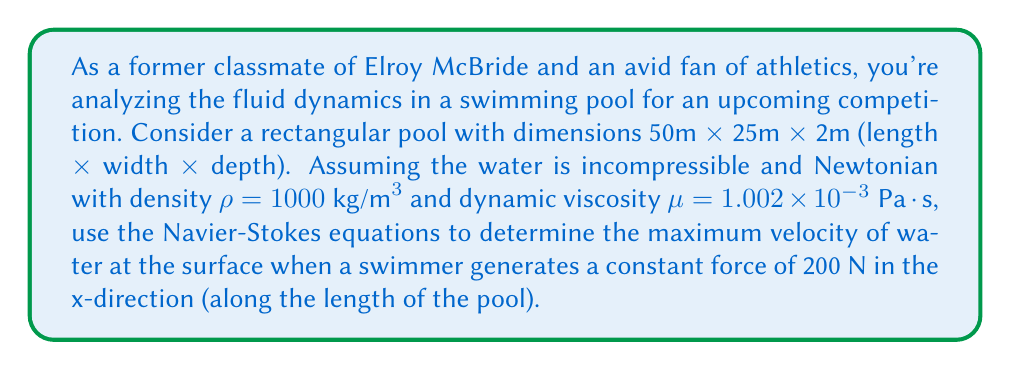Can you solve this math problem? To solve this problem, we'll use the Navier-Stokes equations for incompressible flow in steady-state conditions:

$$\rho(\mathbf{u} \cdot \nabla)\mathbf{u} = -\nabla p + \mu\nabla^2\mathbf{u} + \mathbf{F}$$

Where:
$\rho$ is the density of water
$\mathbf{u}$ is the velocity vector
$p$ is the pressure
$\mu$ is the dynamic viscosity
$\mathbf{F}$ is the external force per unit volume

Given the problem's setup, we can make some simplifying assumptions:
1. The flow is primarily in the x-direction
2. The velocity varies mainly in the z-direction (depth)
3. Pressure gradient is negligible

With these assumptions, the Navier-Stokes equation simplifies to:

$$\mu\frac{d^2u_x}{dz^2} + F_x = 0$$

Where $F_x$ is the force per unit volume in the x-direction.

The force per unit volume is the given force divided by the pool volume:

$$F_x = \frac{200 \text{ N}}{50 \text{ m} \times 25 \text{ m} \times 2 \text{ m}} = 0.08 \text{ N/m}^3$$

The boundary conditions are:
1. No-slip condition at the bottom: $u_x(0) = 0$
2. No shear stress at the surface: $\frac{du_x}{dz}(2) = 0$

Integrating the simplified Navier-Stokes equation twice:

$$\frac{du_x}{dz} = -\frac{F_x}{\mu}z + C_1$$
$$u_x = -\frac{F_x}{2\mu}z^2 + C_1z + C_2$$

Applying the boundary conditions:

1. $u_x(0) = 0$ implies $C_2 = 0$
2. $\frac{du_x}{dz}(2) = 0$ implies $C_1 = \frac{2F_x}{\mu}$

Substituting these constants back into the velocity equation:

$$u_x = \frac{F_x}{2\mu}(4z - z^2)$$

The maximum velocity occurs at the surface (z = 2m):

$$u_{max} = u_x(2) = \frac{F_x}{2\mu}(4 \cdot 2 - 2^2) = \frac{4F_x}{\mu}$$

Substituting the values:

$$u_{max} = \frac{4 \cdot 0.08 \text{ N/m}^3}{1.002 \times 10^{-3} \text{ Pa}\cdot\text{s}} = 319.36 \text{ m/s}$$
Answer: The maximum velocity of water at the surface is approximately 319.36 m/s. 